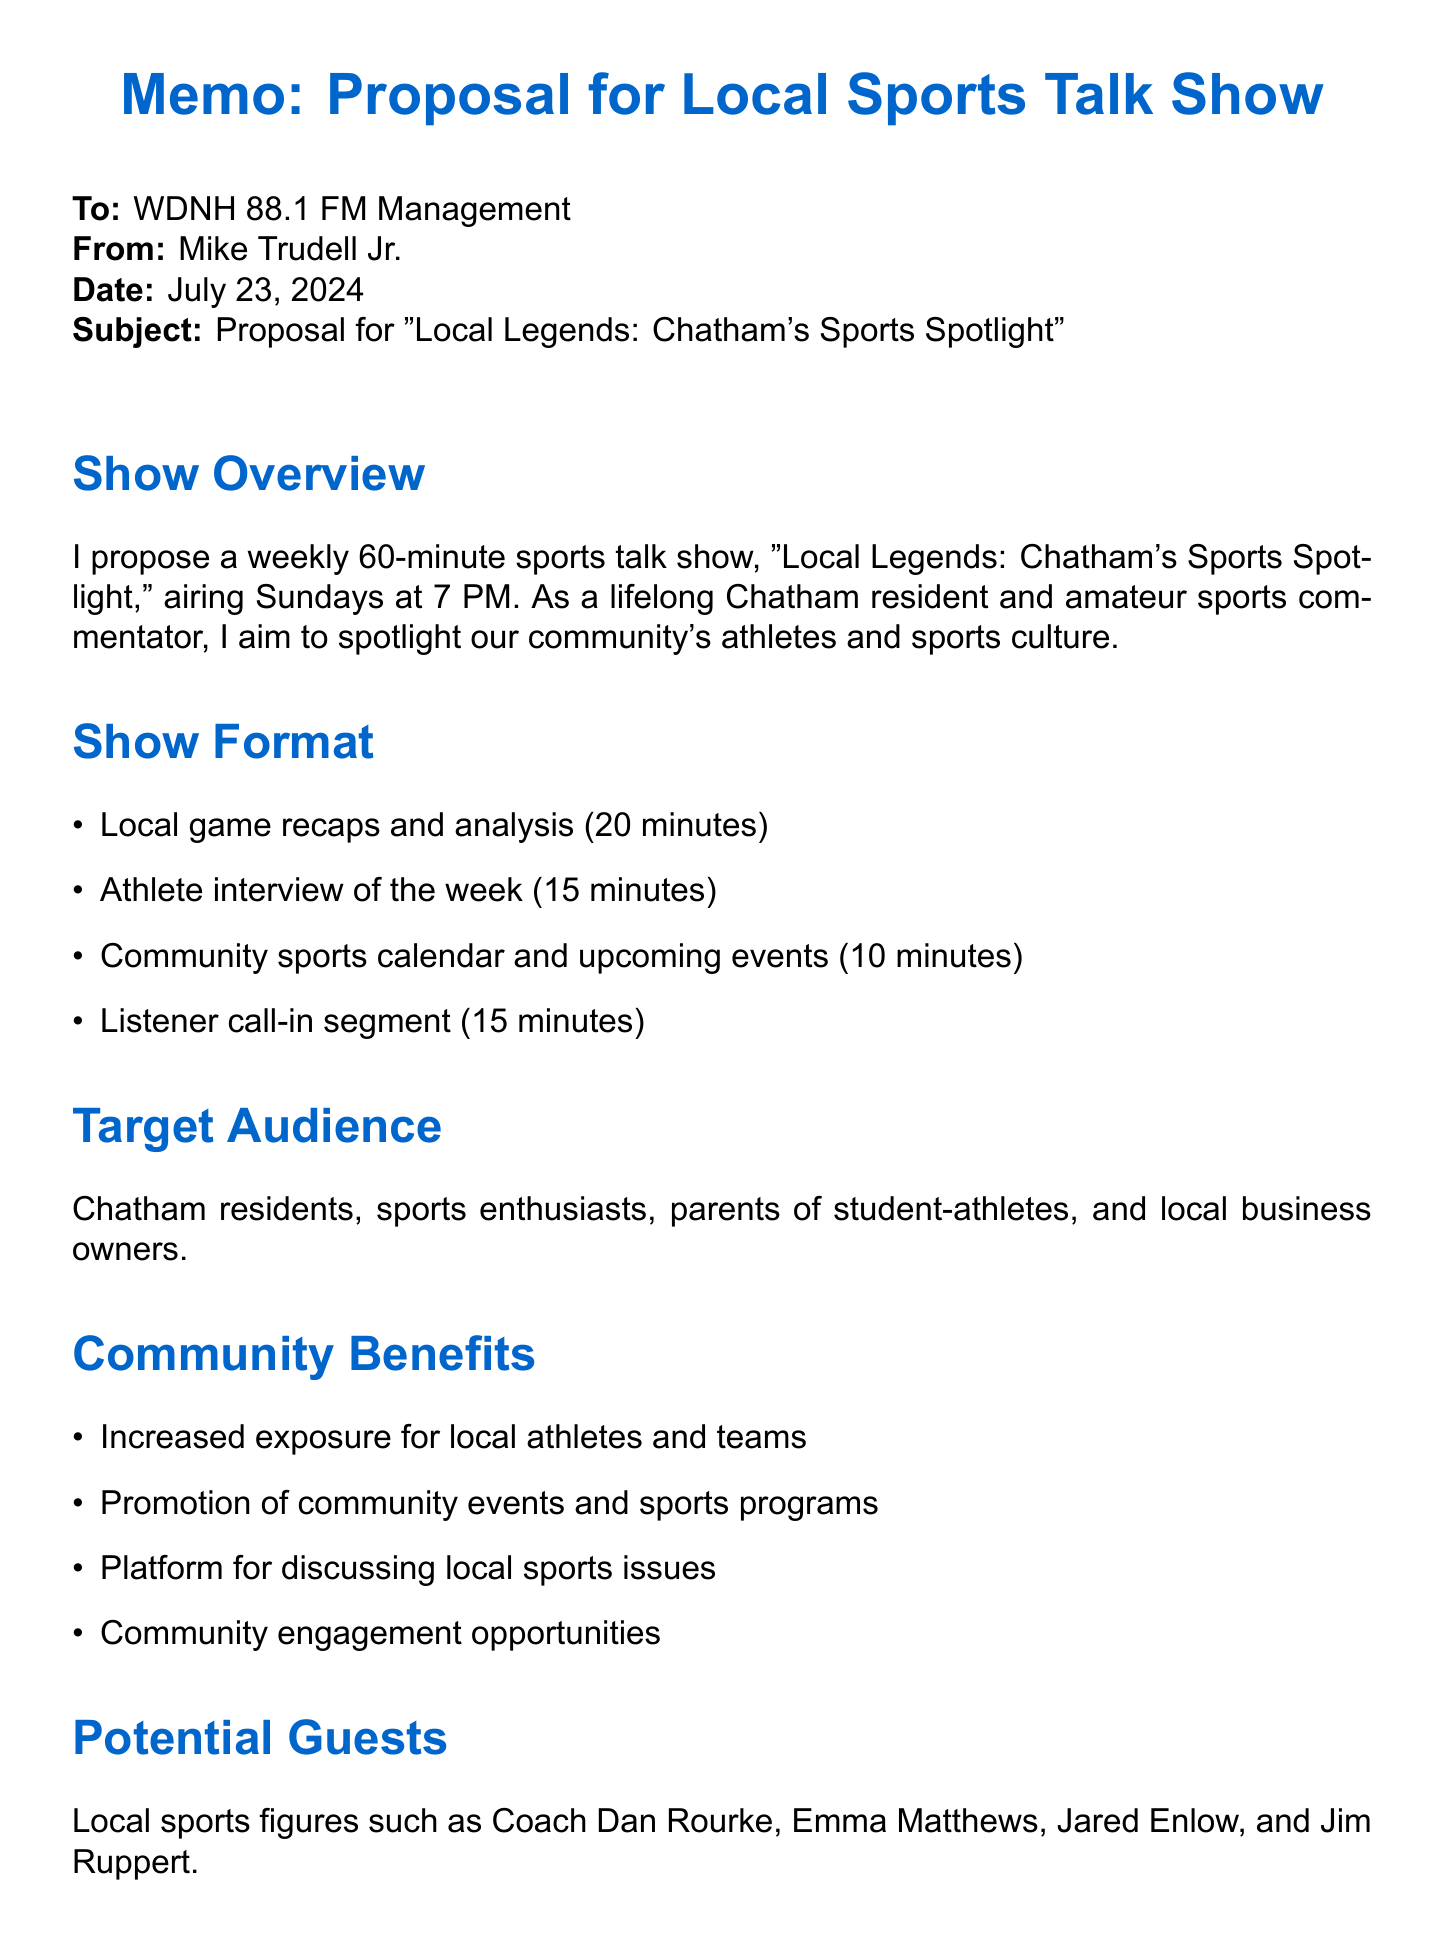what is the show title? The show title is mentioned in the document as "Local Legends: Chatham's Sports Spotlight."
Answer: Local Legends: Chatham's Sports Spotlight who is the host of the show? The document provides the host's name and brief background.
Answer: Mike Trudell Jr how long is each episode? The document specifies the duration of each episode.
Answer: 60 minutes when does the show air? The airing time is detailed in the document.
Answer: Sunday evenings at 7 PM what segment is 15 minutes long? The document lists various segments and their durations; this segment is specified.
Answer: Athlete interview of the week which local sports figure is listed as a potential guest? Potential guests are listed throughout the document, and this name is one example.
Answer: Dan Rourke what is one community benefit of the show? The document outlines several community benefits; this is one example.
Answer: Increased exposure for local athletes and teams how will the show be promoted? The document outlines marketing strategies; this is one of the mentioned methods.
Answer: Social media promotion what is a competitive advantage of the show? The document provides several points as competitive advantages; this is one.
Answer: Exclusive focus on Chatham and surrounding areas what type of technical equipment is required? The document provides a list of necessary technical equipment for the show.
Answer: Professional-grade microphones 